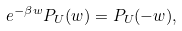<formula> <loc_0><loc_0><loc_500><loc_500>e ^ { - \beta w } P _ { U } ( w ) = P _ { U } ( - w ) ,</formula> 